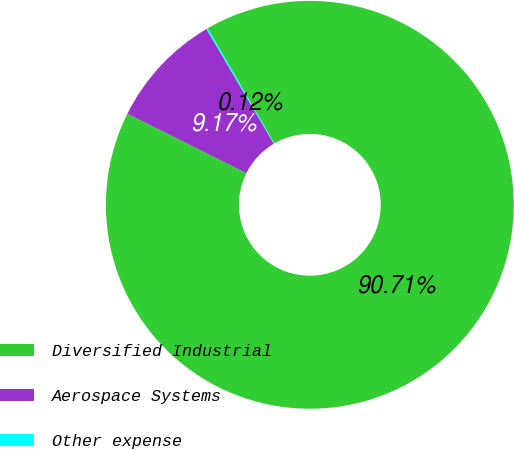<chart> <loc_0><loc_0><loc_500><loc_500><pie_chart><fcel>Diversified Industrial<fcel>Aerospace Systems<fcel>Other expense<nl><fcel>90.71%<fcel>9.17%<fcel>0.12%<nl></chart> 